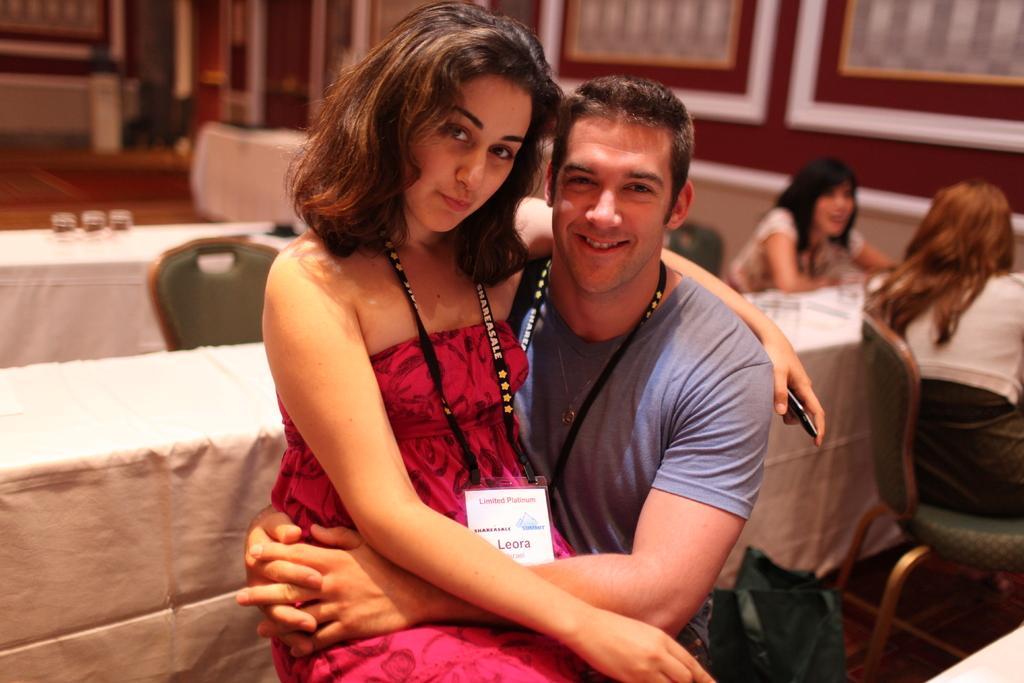Can you describe this image briefly? In the center of the image we can see man and woman sitting. In the background we can see chairs, tables, glasses, persons, door and wall. 